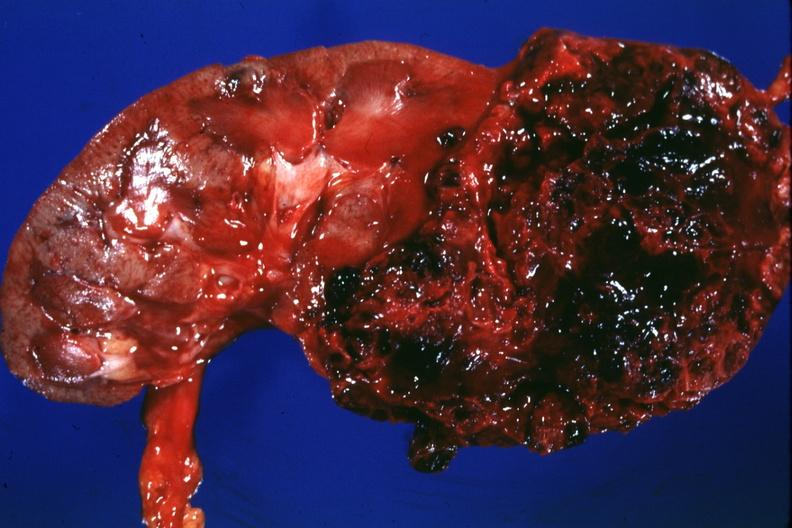s single metastatic appearing lesion present?
Answer the question using a single word or phrase. No 